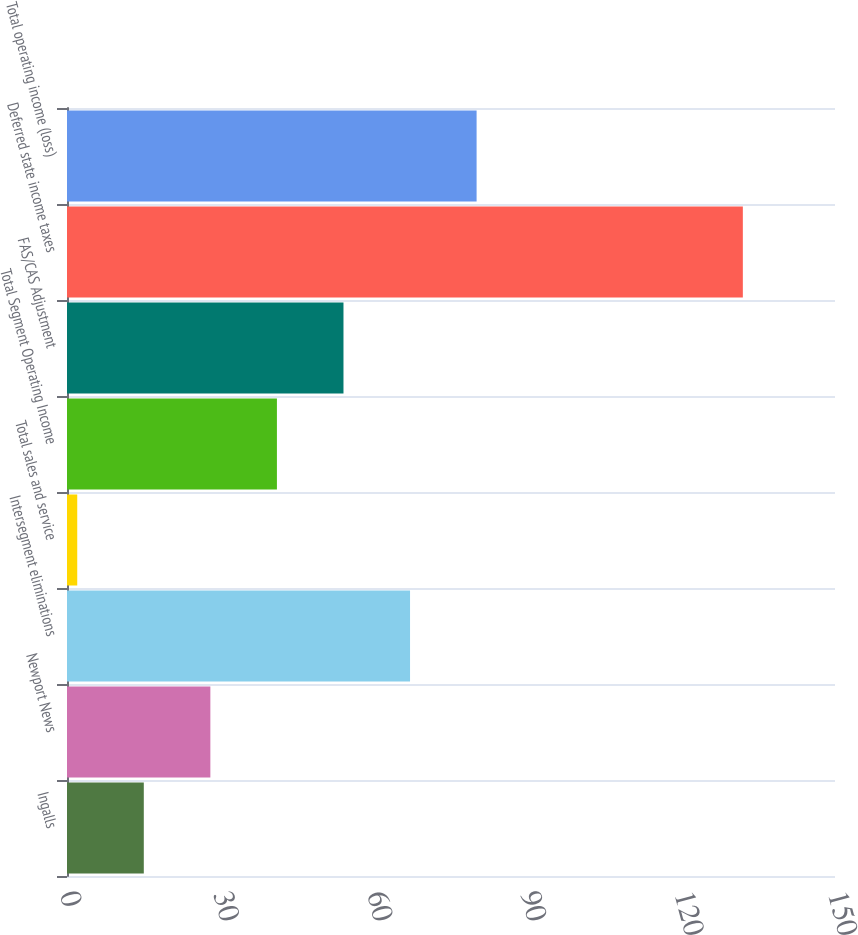<chart> <loc_0><loc_0><loc_500><loc_500><bar_chart><fcel>Ingalls<fcel>Newport News<fcel>Intersegment eliminations<fcel>Total sales and service<fcel>Total Segment Operating Income<fcel>FAS/CAS Adjustment<fcel>Deferred state income taxes<fcel>Total operating income (loss)<nl><fcel>15<fcel>28<fcel>67<fcel>2<fcel>41<fcel>54<fcel>132<fcel>80<nl></chart> 